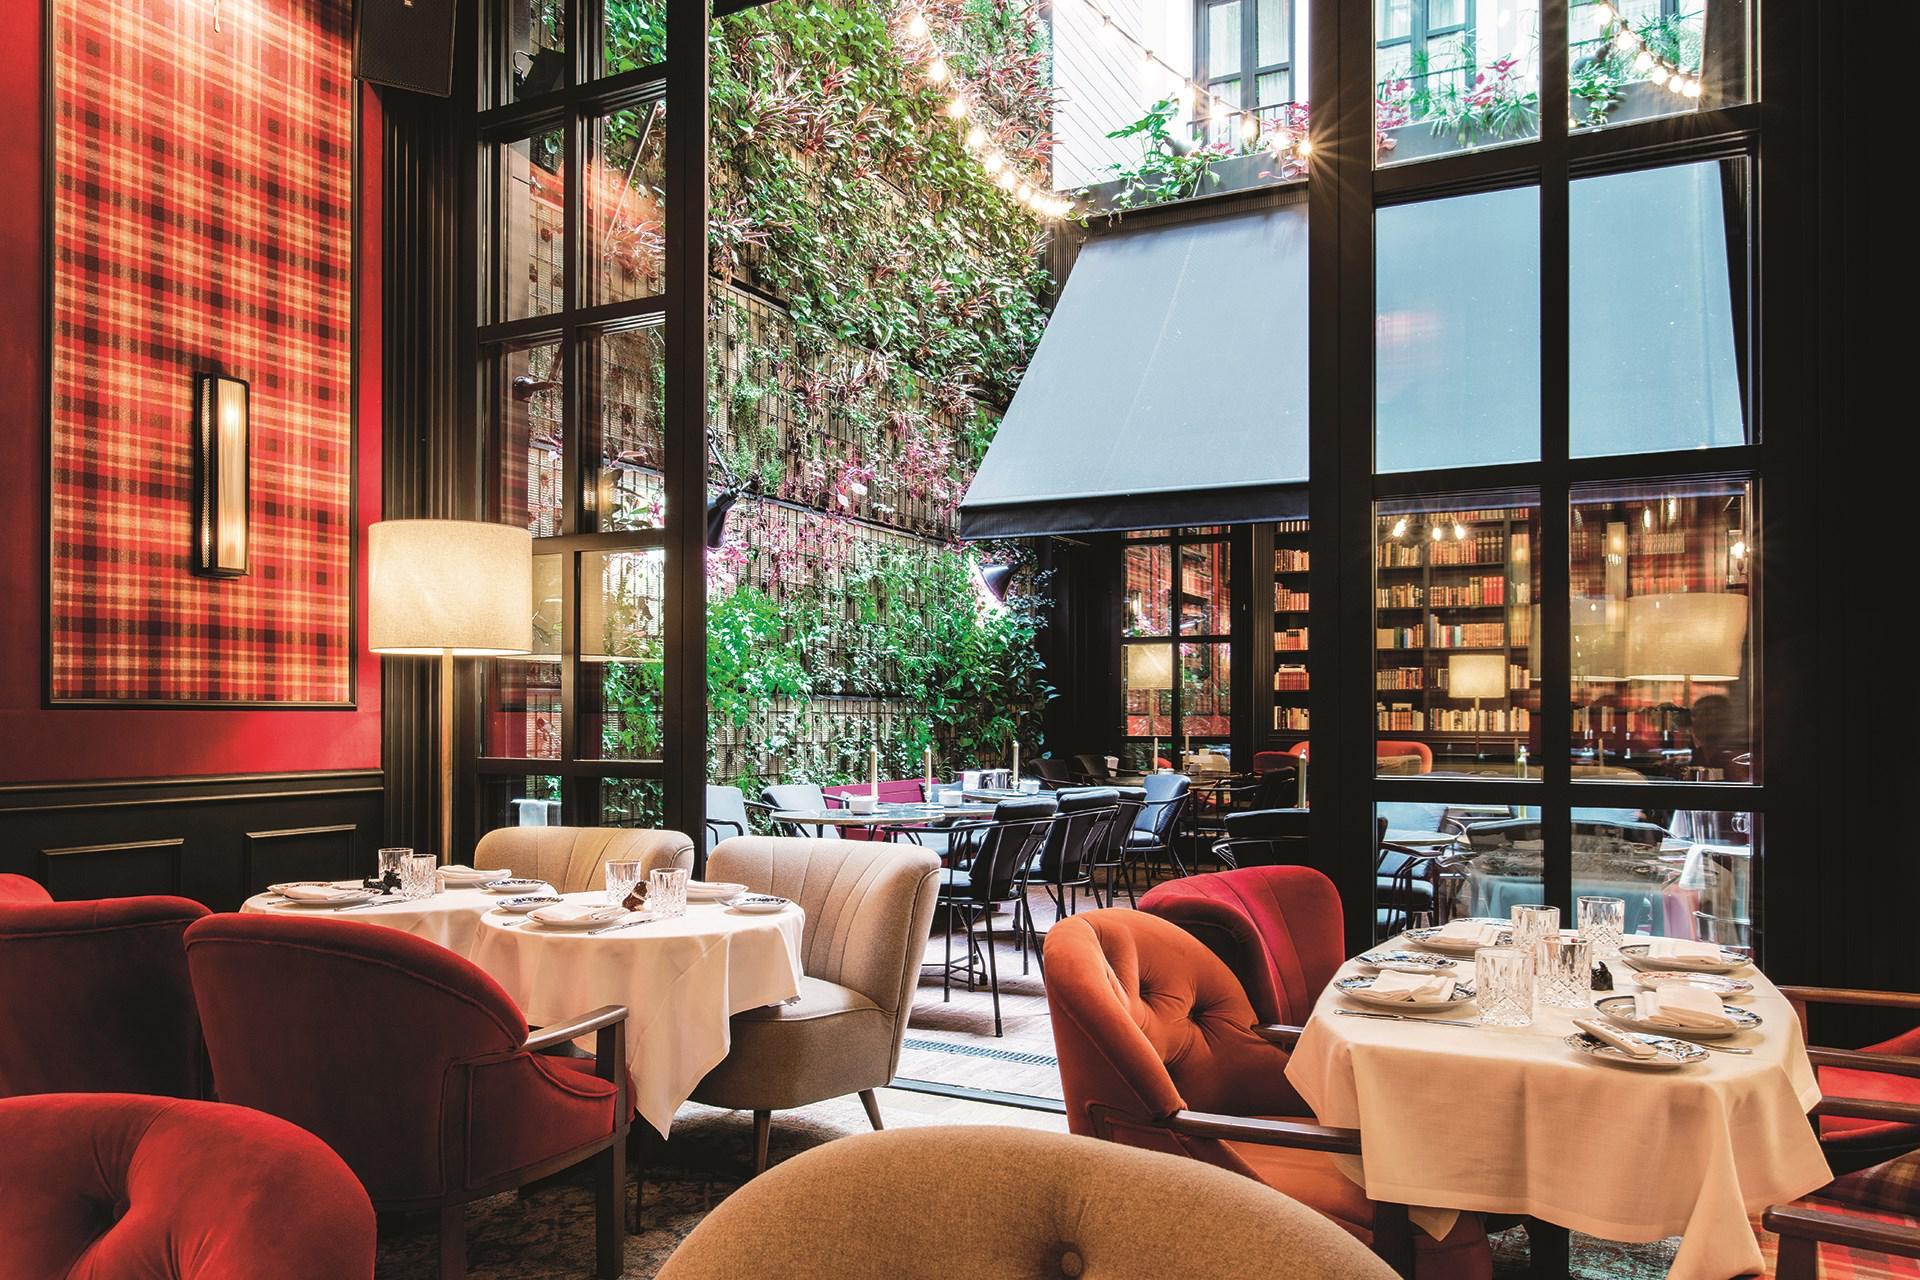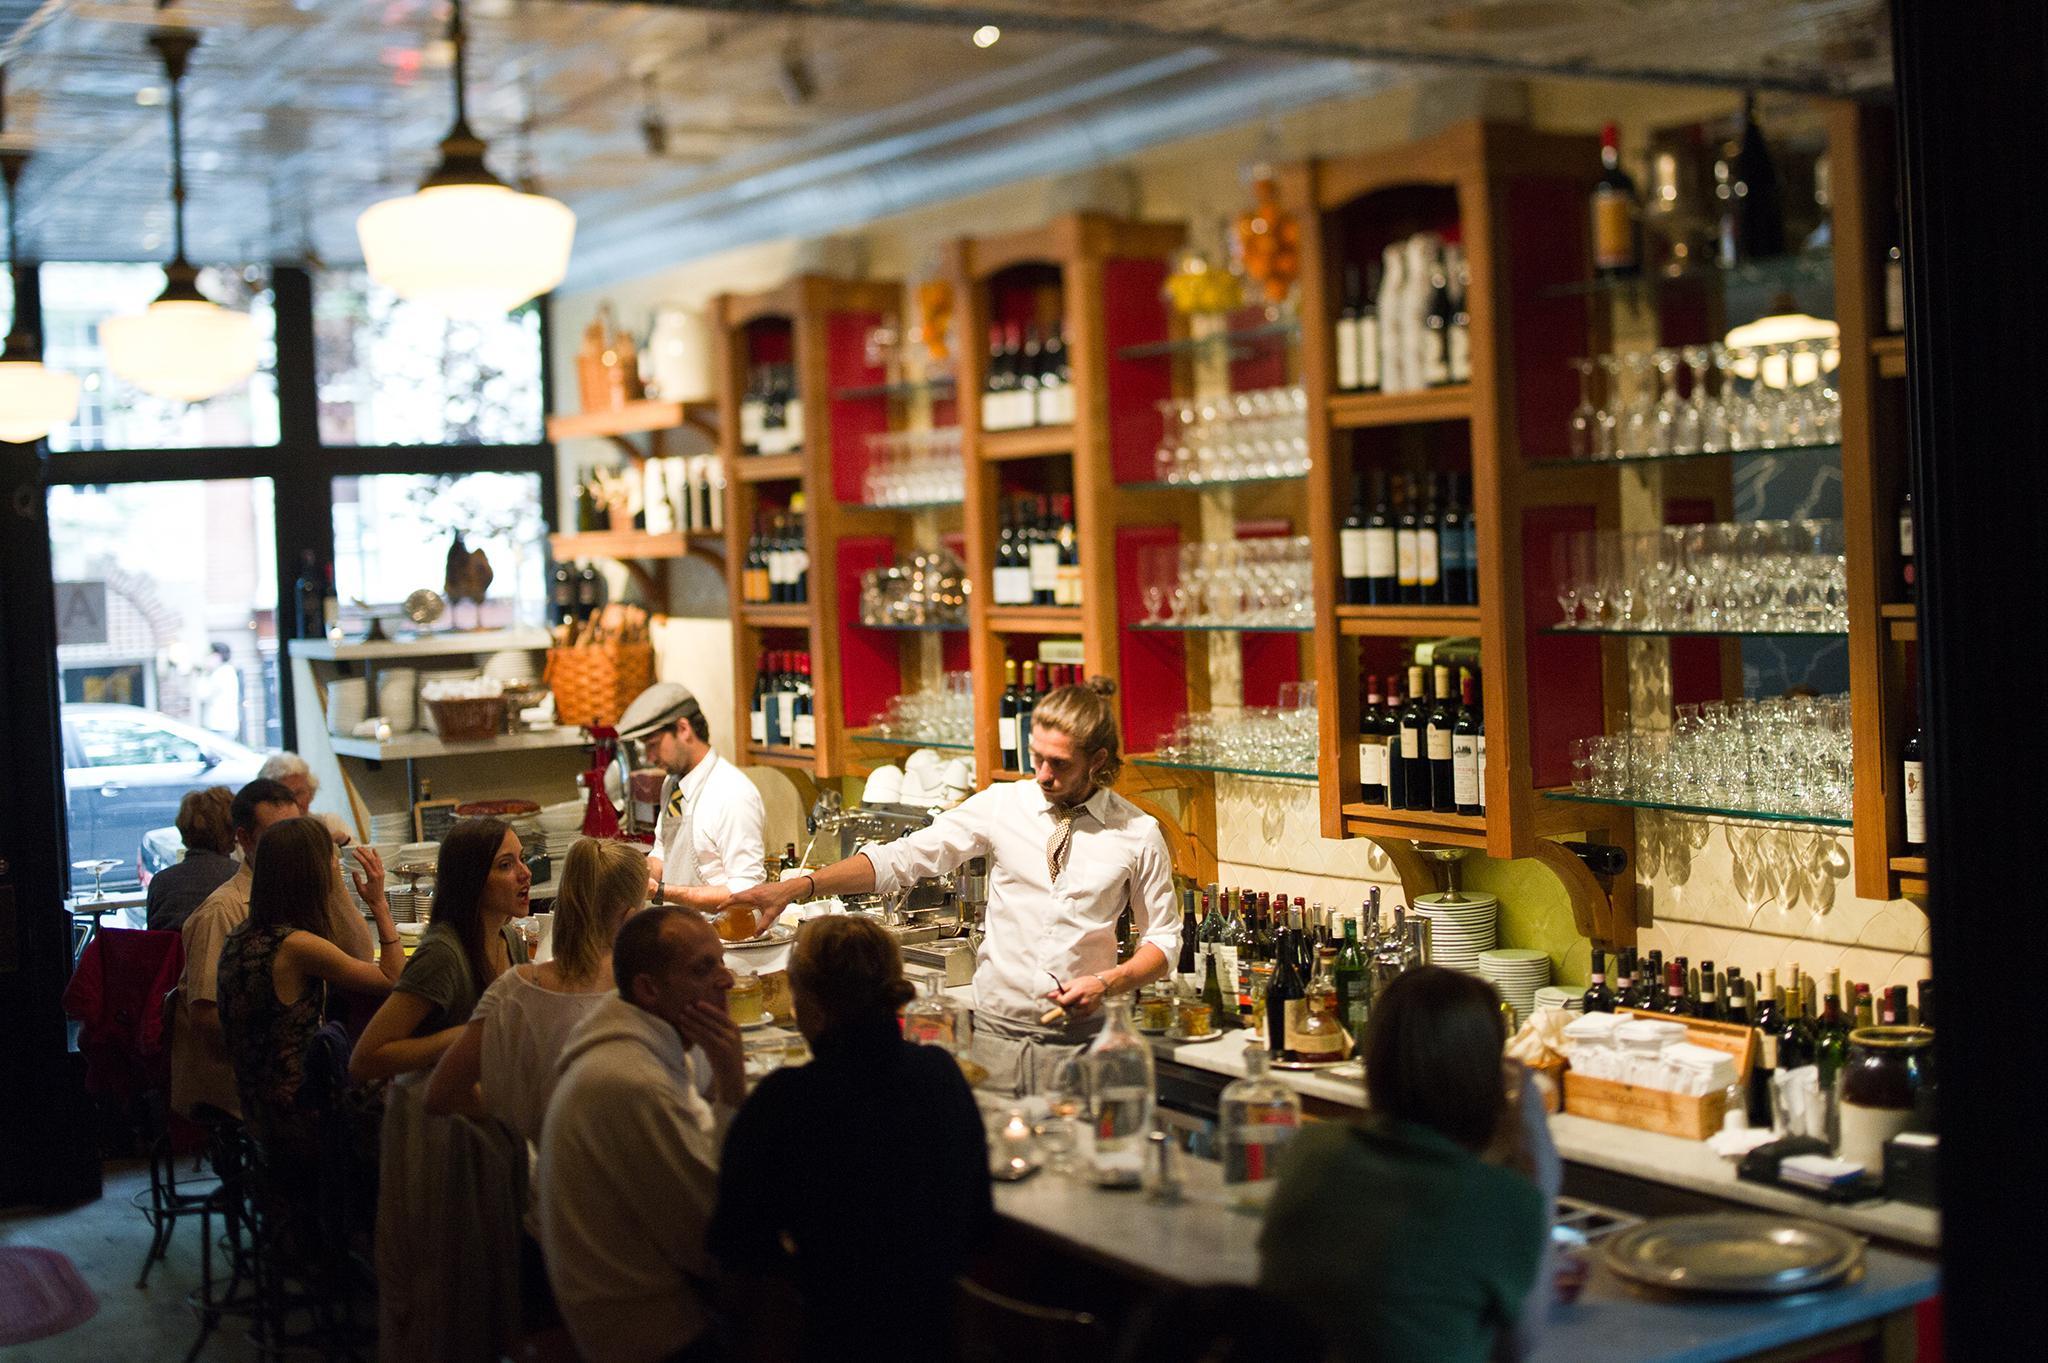The first image is the image on the left, the second image is the image on the right. Evaluate the accuracy of this statement regarding the images: "In one image, shelves of bottles are behind multiple bartenders in white shirts with neckties, who stand in front of a bar counter.". Is it true? Answer yes or no. Yes. 